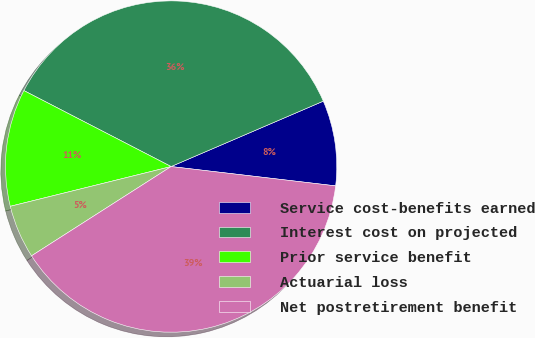<chart> <loc_0><loc_0><loc_500><loc_500><pie_chart><fcel>Service cost-benefits earned<fcel>Interest cost on projected<fcel>Prior service benefit<fcel>Actuarial loss<fcel>Net postretirement benefit<nl><fcel>8.32%<fcel>35.96%<fcel>11.44%<fcel>5.2%<fcel>39.08%<nl></chart> 